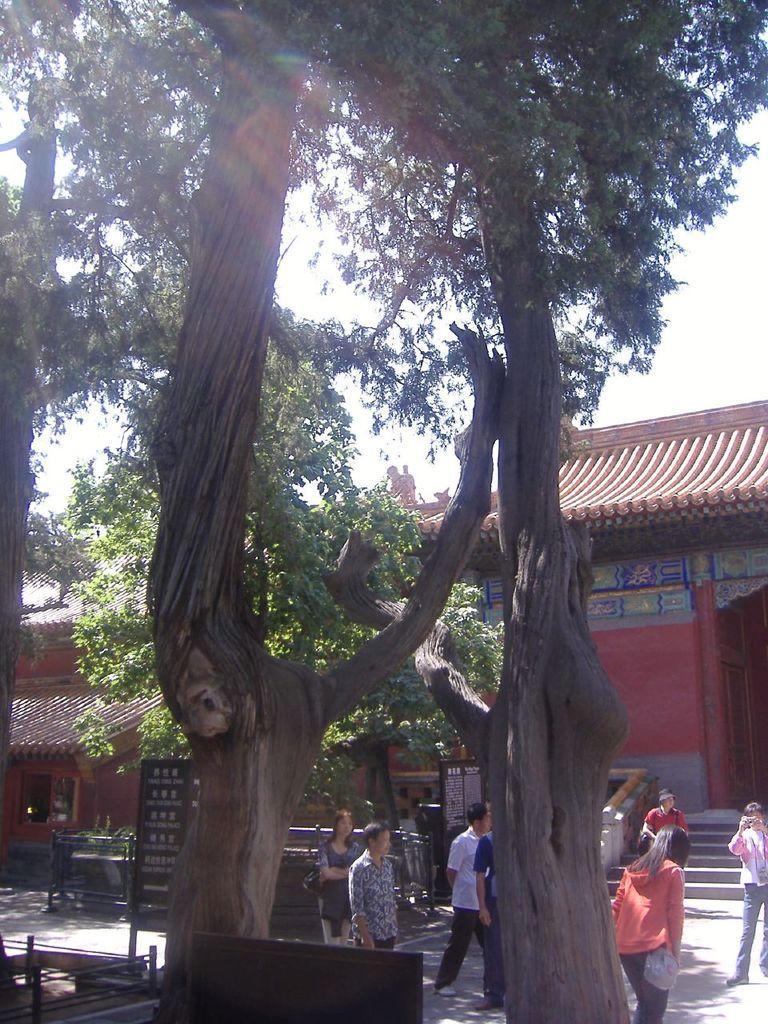How would you summarize this image in a sentence or two? In the image there are trees. Behind the trees there are few people standing. And in the background there are houses with walls, roofs, posters and doors. In the background at the top of the image there is a sky. 